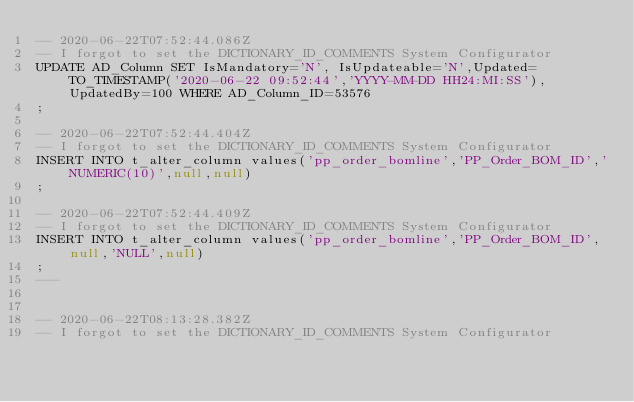Convert code to text. <code><loc_0><loc_0><loc_500><loc_500><_SQL_>-- 2020-06-22T07:52:44.086Z
-- I forgot to set the DICTIONARY_ID_COMMENTS System Configurator
UPDATE AD_Column SET IsMandatory='N', IsUpdateable='N',Updated=TO_TIMESTAMP('2020-06-22 09:52:44','YYYY-MM-DD HH24:MI:SS'),UpdatedBy=100 WHERE AD_Column_ID=53576
;

-- 2020-06-22T07:52:44.404Z
-- I forgot to set the DICTIONARY_ID_COMMENTS System Configurator
INSERT INTO t_alter_column values('pp_order_bomline','PP_Order_BOM_ID','NUMERIC(10)',null,null)
;

-- 2020-06-22T07:52:44.409Z
-- I forgot to set the DICTIONARY_ID_COMMENTS System Configurator
INSERT INTO t_alter_column values('pp_order_bomline','PP_Order_BOM_ID',null,'NULL',null)
;
---


-- 2020-06-22T08:13:28.382Z
-- I forgot to set the DICTIONARY_ID_COMMENTS System Configurator</code> 